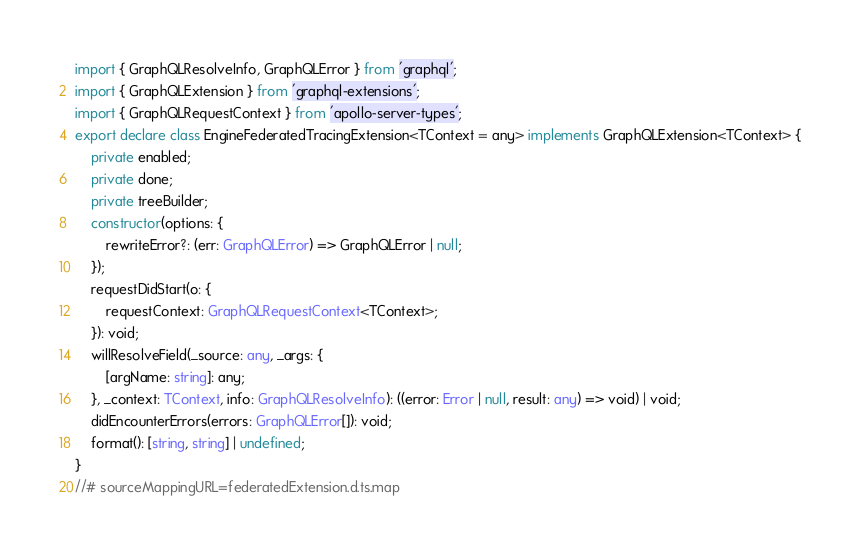Convert code to text. <code><loc_0><loc_0><loc_500><loc_500><_TypeScript_>import { GraphQLResolveInfo, GraphQLError } from 'graphql';
import { GraphQLExtension } from 'graphql-extensions';
import { GraphQLRequestContext } from 'apollo-server-types';
export declare class EngineFederatedTracingExtension<TContext = any> implements GraphQLExtension<TContext> {
    private enabled;
    private done;
    private treeBuilder;
    constructor(options: {
        rewriteError?: (err: GraphQLError) => GraphQLError | null;
    });
    requestDidStart(o: {
        requestContext: GraphQLRequestContext<TContext>;
    }): void;
    willResolveField(_source: any, _args: {
        [argName: string]: any;
    }, _context: TContext, info: GraphQLResolveInfo): ((error: Error | null, result: any) => void) | void;
    didEncounterErrors(errors: GraphQLError[]): void;
    format(): [string, string] | undefined;
}
//# sourceMappingURL=federatedExtension.d.ts.map</code> 